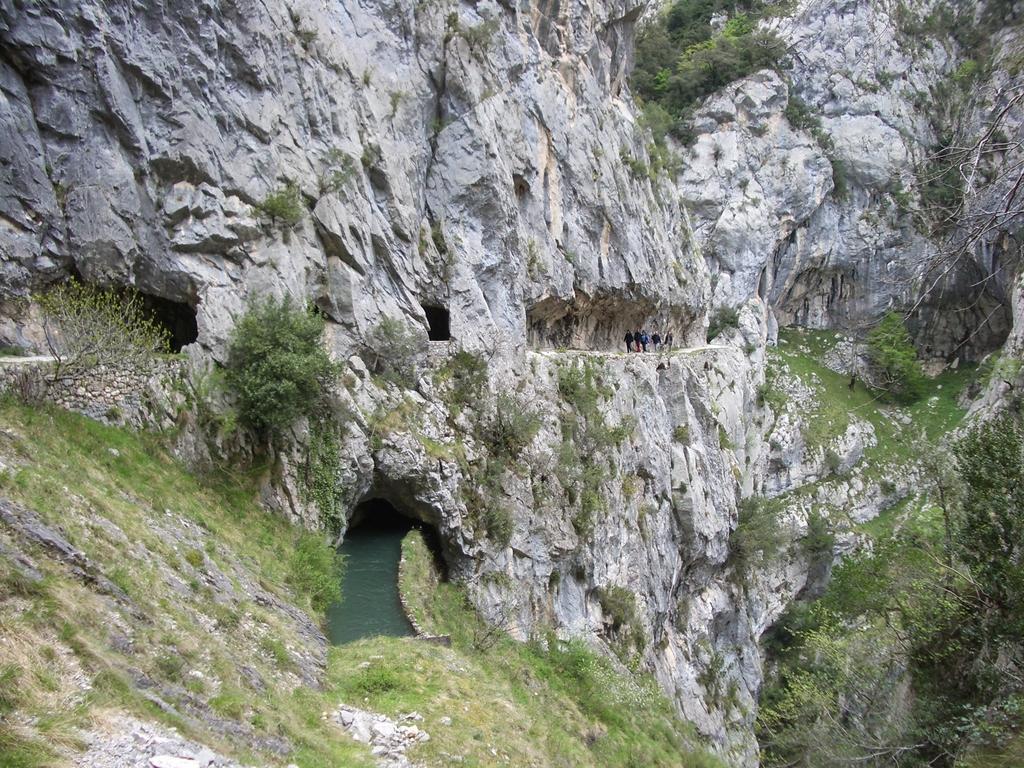Please provide a concise description of this image. In this image I can see the water and few people are standing on the mountain. I can see few trees and the plants. 